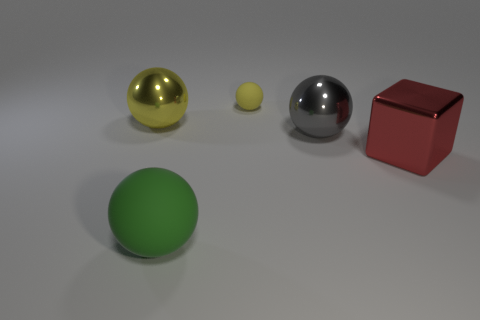Add 3 gray spheres. How many objects exist? 8 Subtract all balls. How many objects are left? 1 Add 5 metal balls. How many metal balls are left? 7 Add 2 big purple cubes. How many big purple cubes exist? 2 Subtract 0 red cylinders. How many objects are left? 5 Subtract all tiny blue matte things. Subtract all small balls. How many objects are left? 4 